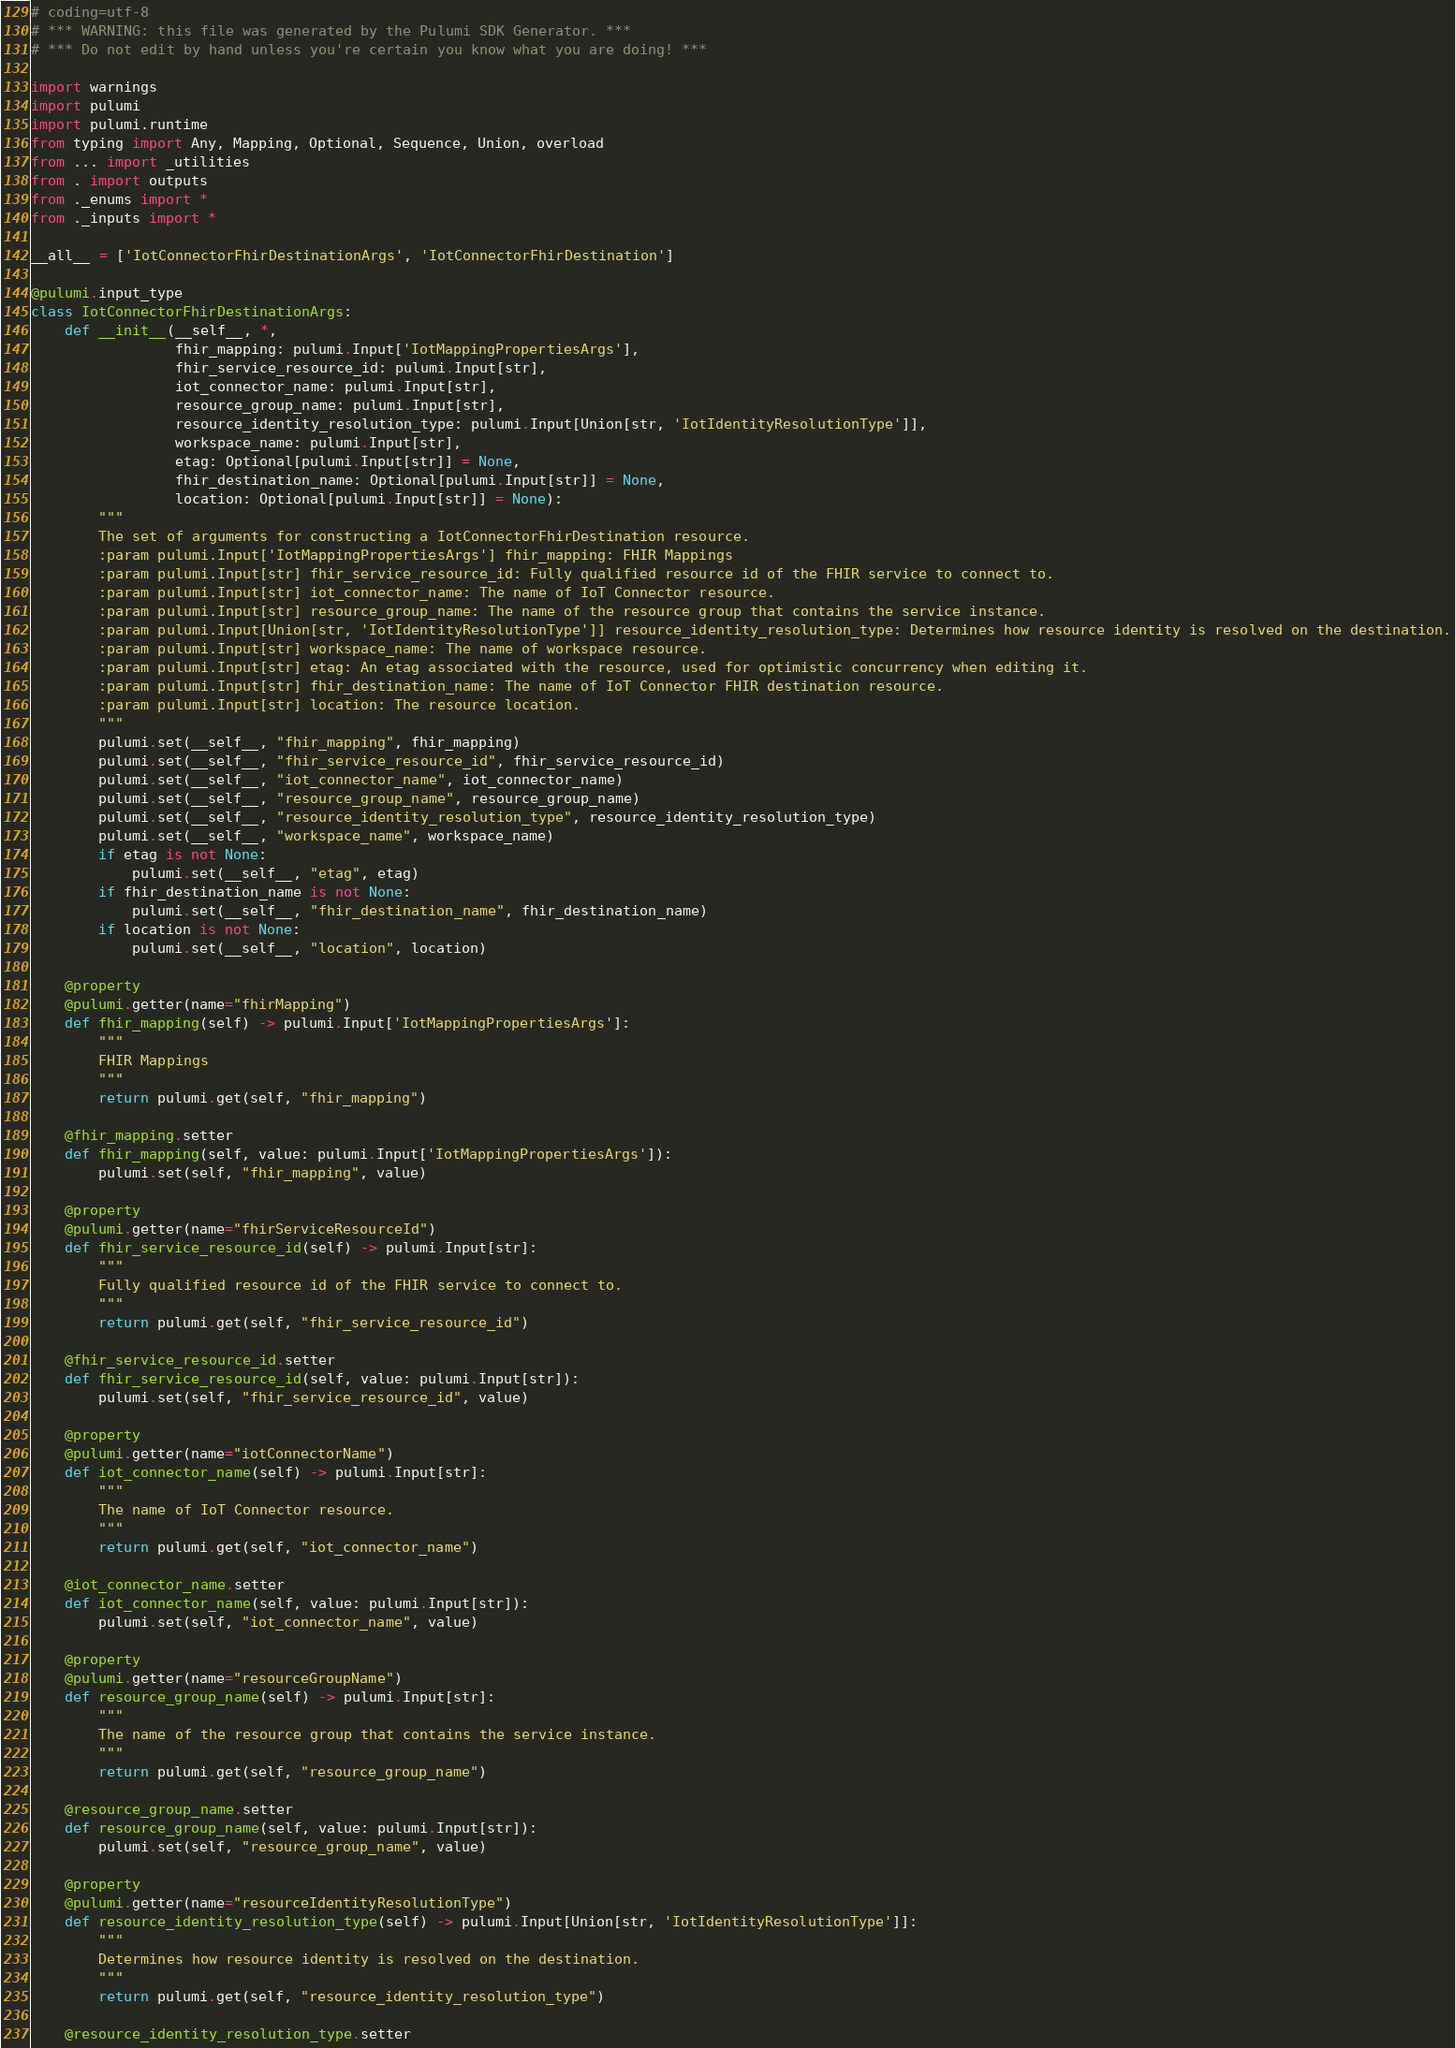Convert code to text. <code><loc_0><loc_0><loc_500><loc_500><_Python_># coding=utf-8
# *** WARNING: this file was generated by the Pulumi SDK Generator. ***
# *** Do not edit by hand unless you're certain you know what you are doing! ***

import warnings
import pulumi
import pulumi.runtime
from typing import Any, Mapping, Optional, Sequence, Union, overload
from ... import _utilities
from . import outputs
from ._enums import *
from ._inputs import *

__all__ = ['IotConnectorFhirDestinationArgs', 'IotConnectorFhirDestination']

@pulumi.input_type
class IotConnectorFhirDestinationArgs:
    def __init__(__self__, *,
                 fhir_mapping: pulumi.Input['IotMappingPropertiesArgs'],
                 fhir_service_resource_id: pulumi.Input[str],
                 iot_connector_name: pulumi.Input[str],
                 resource_group_name: pulumi.Input[str],
                 resource_identity_resolution_type: pulumi.Input[Union[str, 'IotIdentityResolutionType']],
                 workspace_name: pulumi.Input[str],
                 etag: Optional[pulumi.Input[str]] = None,
                 fhir_destination_name: Optional[pulumi.Input[str]] = None,
                 location: Optional[pulumi.Input[str]] = None):
        """
        The set of arguments for constructing a IotConnectorFhirDestination resource.
        :param pulumi.Input['IotMappingPropertiesArgs'] fhir_mapping: FHIR Mappings
        :param pulumi.Input[str] fhir_service_resource_id: Fully qualified resource id of the FHIR service to connect to.
        :param pulumi.Input[str] iot_connector_name: The name of IoT Connector resource.
        :param pulumi.Input[str] resource_group_name: The name of the resource group that contains the service instance.
        :param pulumi.Input[Union[str, 'IotIdentityResolutionType']] resource_identity_resolution_type: Determines how resource identity is resolved on the destination.
        :param pulumi.Input[str] workspace_name: The name of workspace resource.
        :param pulumi.Input[str] etag: An etag associated with the resource, used for optimistic concurrency when editing it.
        :param pulumi.Input[str] fhir_destination_name: The name of IoT Connector FHIR destination resource.
        :param pulumi.Input[str] location: The resource location.
        """
        pulumi.set(__self__, "fhir_mapping", fhir_mapping)
        pulumi.set(__self__, "fhir_service_resource_id", fhir_service_resource_id)
        pulumi.set(__self__, "iot_connector_name", iot_connector_name)
        pulumi.set(__self__, "resource_group_name", resource_group_name)
        pulumi.set(__self__, "resource_identity_resolution_type", resource_identity_resolution_type)
        pulumi.set(__self__, "workspace_name", workspace_name)
        if etag is not None:
            pulumi.set(__self__, "etag", etag)
        if fhir_destination_name is not None:
            pulumi.set(__self__, "fhir_destination_name", fhir_destination_name)
        if location is not None:
            pulumi.set(__self__, "location", location)

    @property
    @pulumi.getter(name="fhirMapping")
    def fhir_mapping(self) -> pulumi.Input['IotMappingPropertiesArgs']:
        """
        FHIR Mappings
        """
        return pulumi.get(self, "fhir_mapping")

    @fhir_mapping.setter
    def fhir_mapping(self, value: pulumi.Input['IotMappingPropertiesArgs']):
        pulumi.set(self, "fhir_mapping", value)

    @property
    @pulumi.getter(name="fhirServiceResourceId")
    def fhir_service_resource_id(self) -> pulumi.Input[str]:
        """
        Fully qualified resource id of the FHIR service to connect to.
        """
        return pulumi.get(self, "fhir_service_resource_id")

    @fhir_service_resource_id.setter
    def fhir_service_resource_id(self, value: pulumi.Input[str]):
        pulumi.set(self, "fhir_service_resource_id", value)

    @property
    @pulumi.getter(name="iotConnectorName")
    def iot_connector_name(self) -> pulumi.Input[str]:
        """
        The name of IoT Connector resource.
        """
        return pulumi.get(self, "iot_connector_name")

    @iot_connector_name.setter
    def iot_connector_name(self, value: pulumi.Input[str]):
        pulumi.set(self, "iot_connector_name", value)

    @property
    @pulumi.getter(name="resourceGroupName")
    def resource_group_name(self) -> pulumi.Input[str]:
        """
        The name of the resource group that contains the service instance.
        """
        return pulumi.get(self, "resource_group_name")

    @resource_group_name.setter
    def resource_group_name(self, value: pulumi.Input[str]):
        pulumi.set(self, "resource_group_name", value)

    @property
    @pulumi.getter(name="resourceIdentityResolutionType")
    def resource_identity_resolution_type(self) -> pulumi.Input[Union[str, 'IotIdentityResolutionType']]:
        """
        Determines how resource identity is resolved on the destination.
        """
        return pulumi.get(self, "resource_identity_resolution_type")

    @resource_identity_resolution_type.setter</code> 